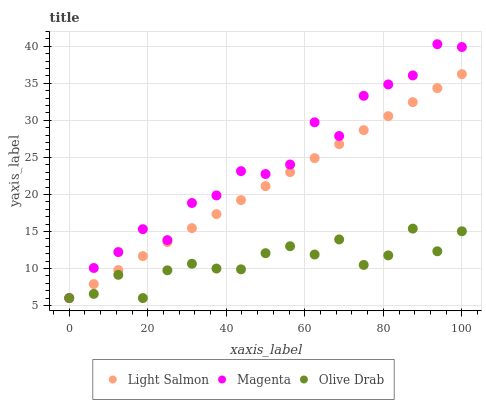Does Olive Drab have the minimum area under the curve?
Answer yes or no. Yes. Does Magenta have the maximum area under the curve?
Answer yes or no. Yes. Does Magenta have the minimum area under the curve?
Answer yes or no. No. Does Olive Drab have the maximum area under the curve?
Answer yes or no. No. Is Light Salmon the smoothest?
Answer yes or no. Yes. Is Magenta the roughest?
Answer yes or no. Yes. Is Olive Drab the smoothest?
Answer yes or no. No. Is Olive Drab the roughest?
Answer yes or no. No. Does Light Salmon have the lowest value?
Answer yes or no. Yes. Does Magenta have the highest value?
Answer yes or no. Yes. Does Olive Drab have the highest value?
Answer yes or no. No. Does Magenta intersect Olive Drab?
Answer yes or no. Yes. Is Magenta less than Olive Drab?
Answer yes or no. No. Is Magenta greater than Olive Drab?
Answer yes or no. No. 